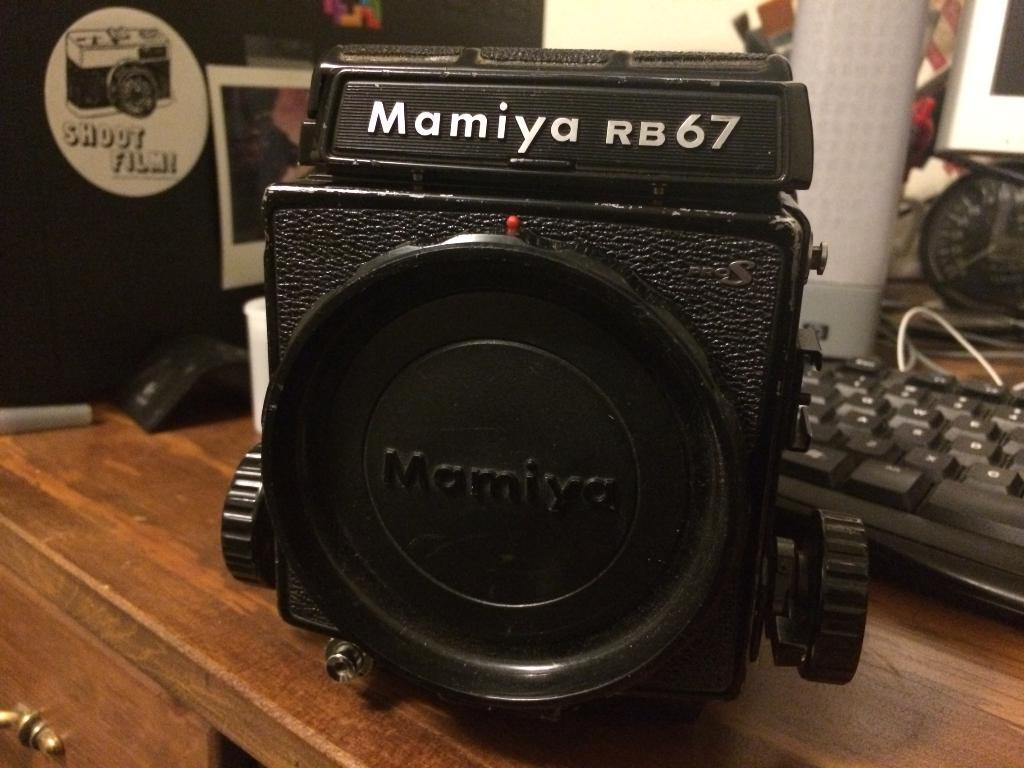<image>
Give a short and clear explanation of the subsequent image. A Mamiya RB67 camera has the lens cap on it. 